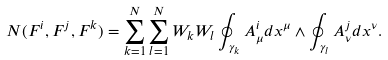<formula> <loc_0><loc_0><loc_500><loc_500>N ( F ^ { i } , F ^ { j } , F ^ { k } ) = \sum ^ { N } _ { k = 1 } \sum ^ { N } _ { l = 1 } W _ { k } W _ { l } \oint _ { \gamma _ { k } } A ^ { i } _ { \mu } d x ^ { \mu } \wedge \oint _ { \gamma _ { l } } A ^ { j } _ { \nu } d x ^ { \nu } .</formula> 